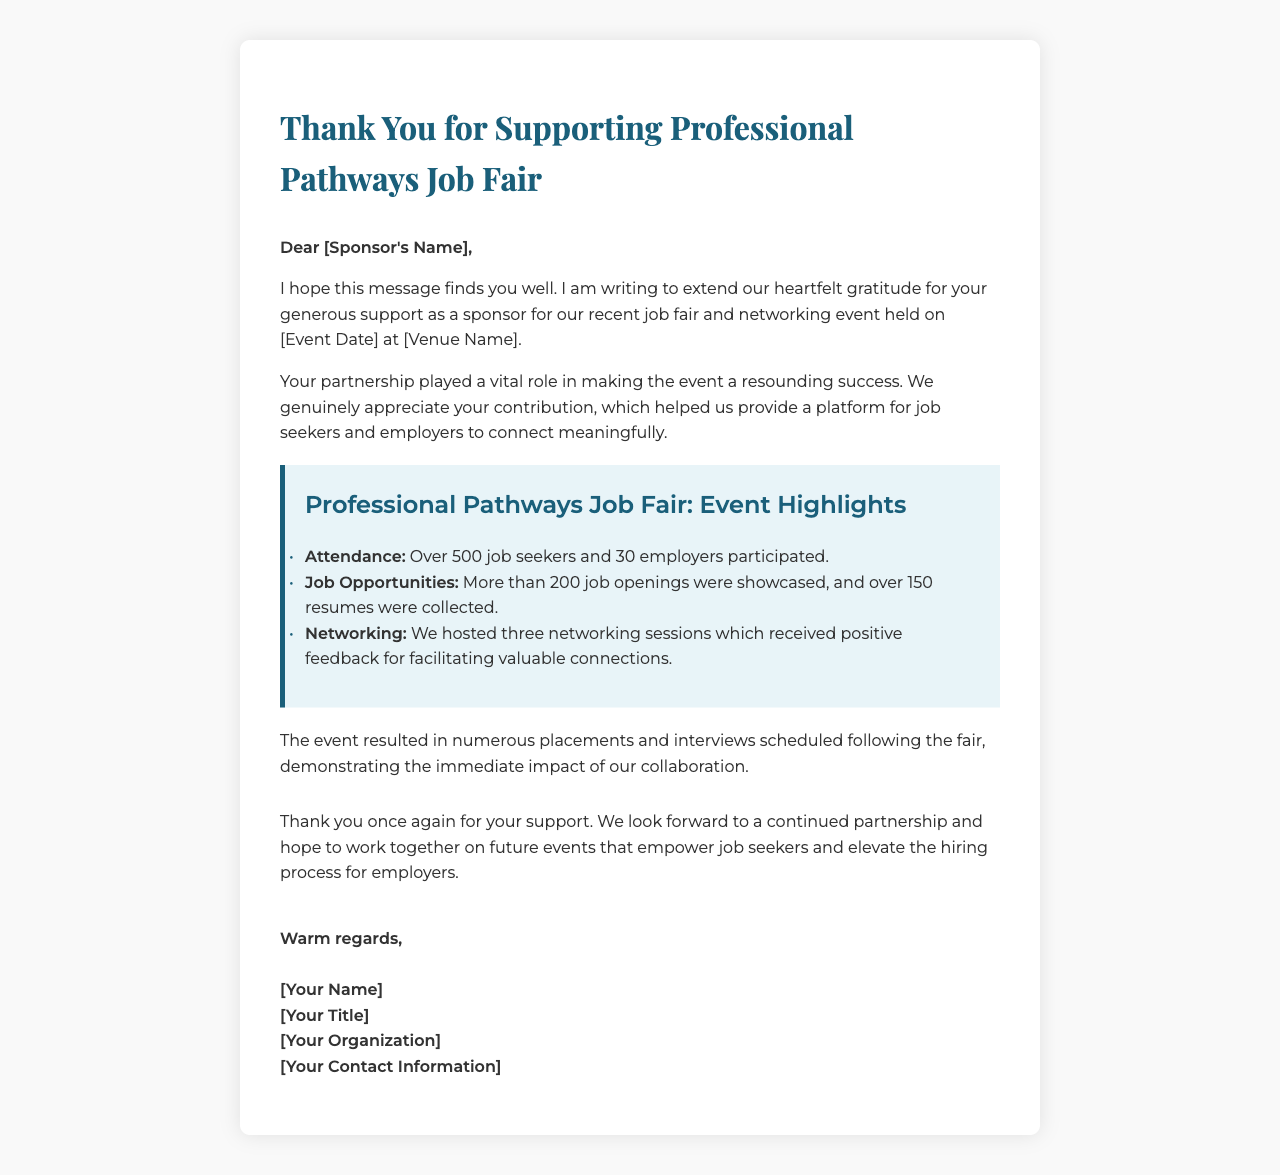What is the name of the event? The name of the event is prominently mentioned in the title of the letter, which is the "Professional Pathways Job Fair."
Answer: Professional Pathways Job Fair When was the event held? The date of the event is stated in the letter, represented as "[Event Date]."
Answer: [Event Date] How many job seekers attended the event? The document mentions that over 500 job seekers participated in the event.
Answer: Over 500 How many employers participated in the event? The letter specifies that 30 employers participated in the job fair.
Answer: 30 employers How many job openings were showcased? According to the document, more than 200 job openings were showcased at the event.
Answer: More than 200 What were the networking sessions' reception? The letter indicates that the networking sessions received positive feedback.
Answer: Positive feedback What impact did the event have after it concluded? The letter notes that the event resulted in numerous placements and scheduled interviews, highlighting the event's effectiveness.
Answer: Numerous placements and interviews scheduled Who is the sender of the letter? The sender's identity is represented in the signature section of the letter, which lists "[Your Name]."
Answer: [Your Name] What is the document type? The structure and content of the letter suggest that it is a thank-you letter aimed at the event's sponsors.
Answer: Thank-you letter 